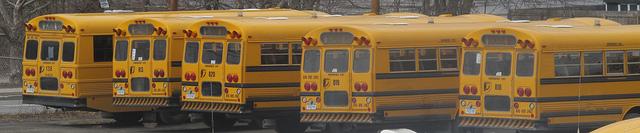What type of buses are these?
Be succinct. School. How many buses are in this photo?
Be succinct. 5. What color are the buses?
Answer briefly. Yellow. Are all the bumpers the same?
Write a very short answer. No. 